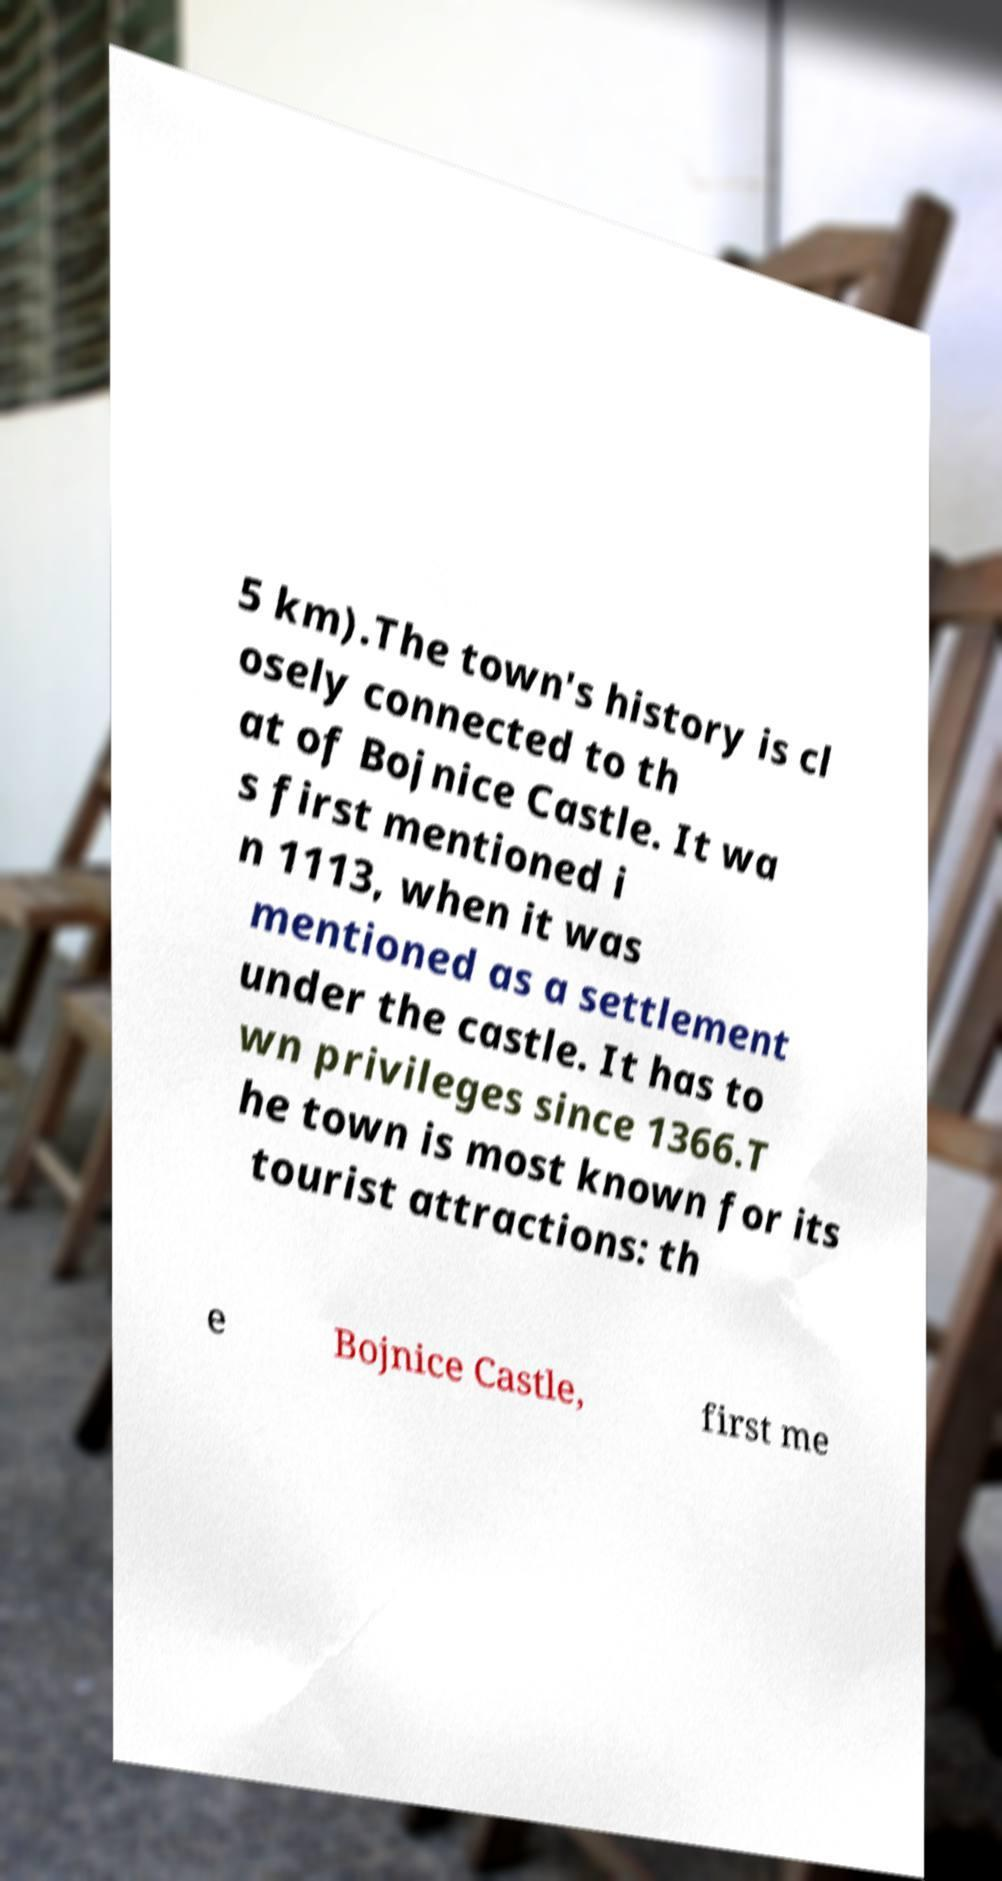Please identify and transcribe the text found in this image. 5 km).The town's history is cl osely connected to th at of Bojnice Castle. It wa s first mentioned i n 1113, when it was mentioned as a settlement under the castle. It has to wn privileges since 1366.T he town is most known for its tourist attractions: th e Bojnice Castle, first me 